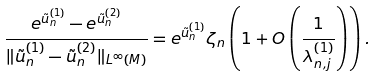<formula> <loc_0><loc_0><loc_500><loc_500>\frac { e ^ { \tilde { u } _ { n } ^ { ( 1 ) } } - e ^ { \tilde { u } _ { n } ^ { ( 2 ) } } } { \| \tilde { u } _ { n } ^ { ( 1 ) } - \tilde { u } _ { n } ^ { ( 2 ) } \| _ { L ^ { \infty } ( M ) } } = e ^ { \tilde { u } _ { n } ^ { ( 1 ) } } \zeta _ { n } \left ( 1 + O \left ( \frac { 1 } { \lambda _ { n , j } ^ { ( 1 ) } } \right ) \right ) .</formula> 